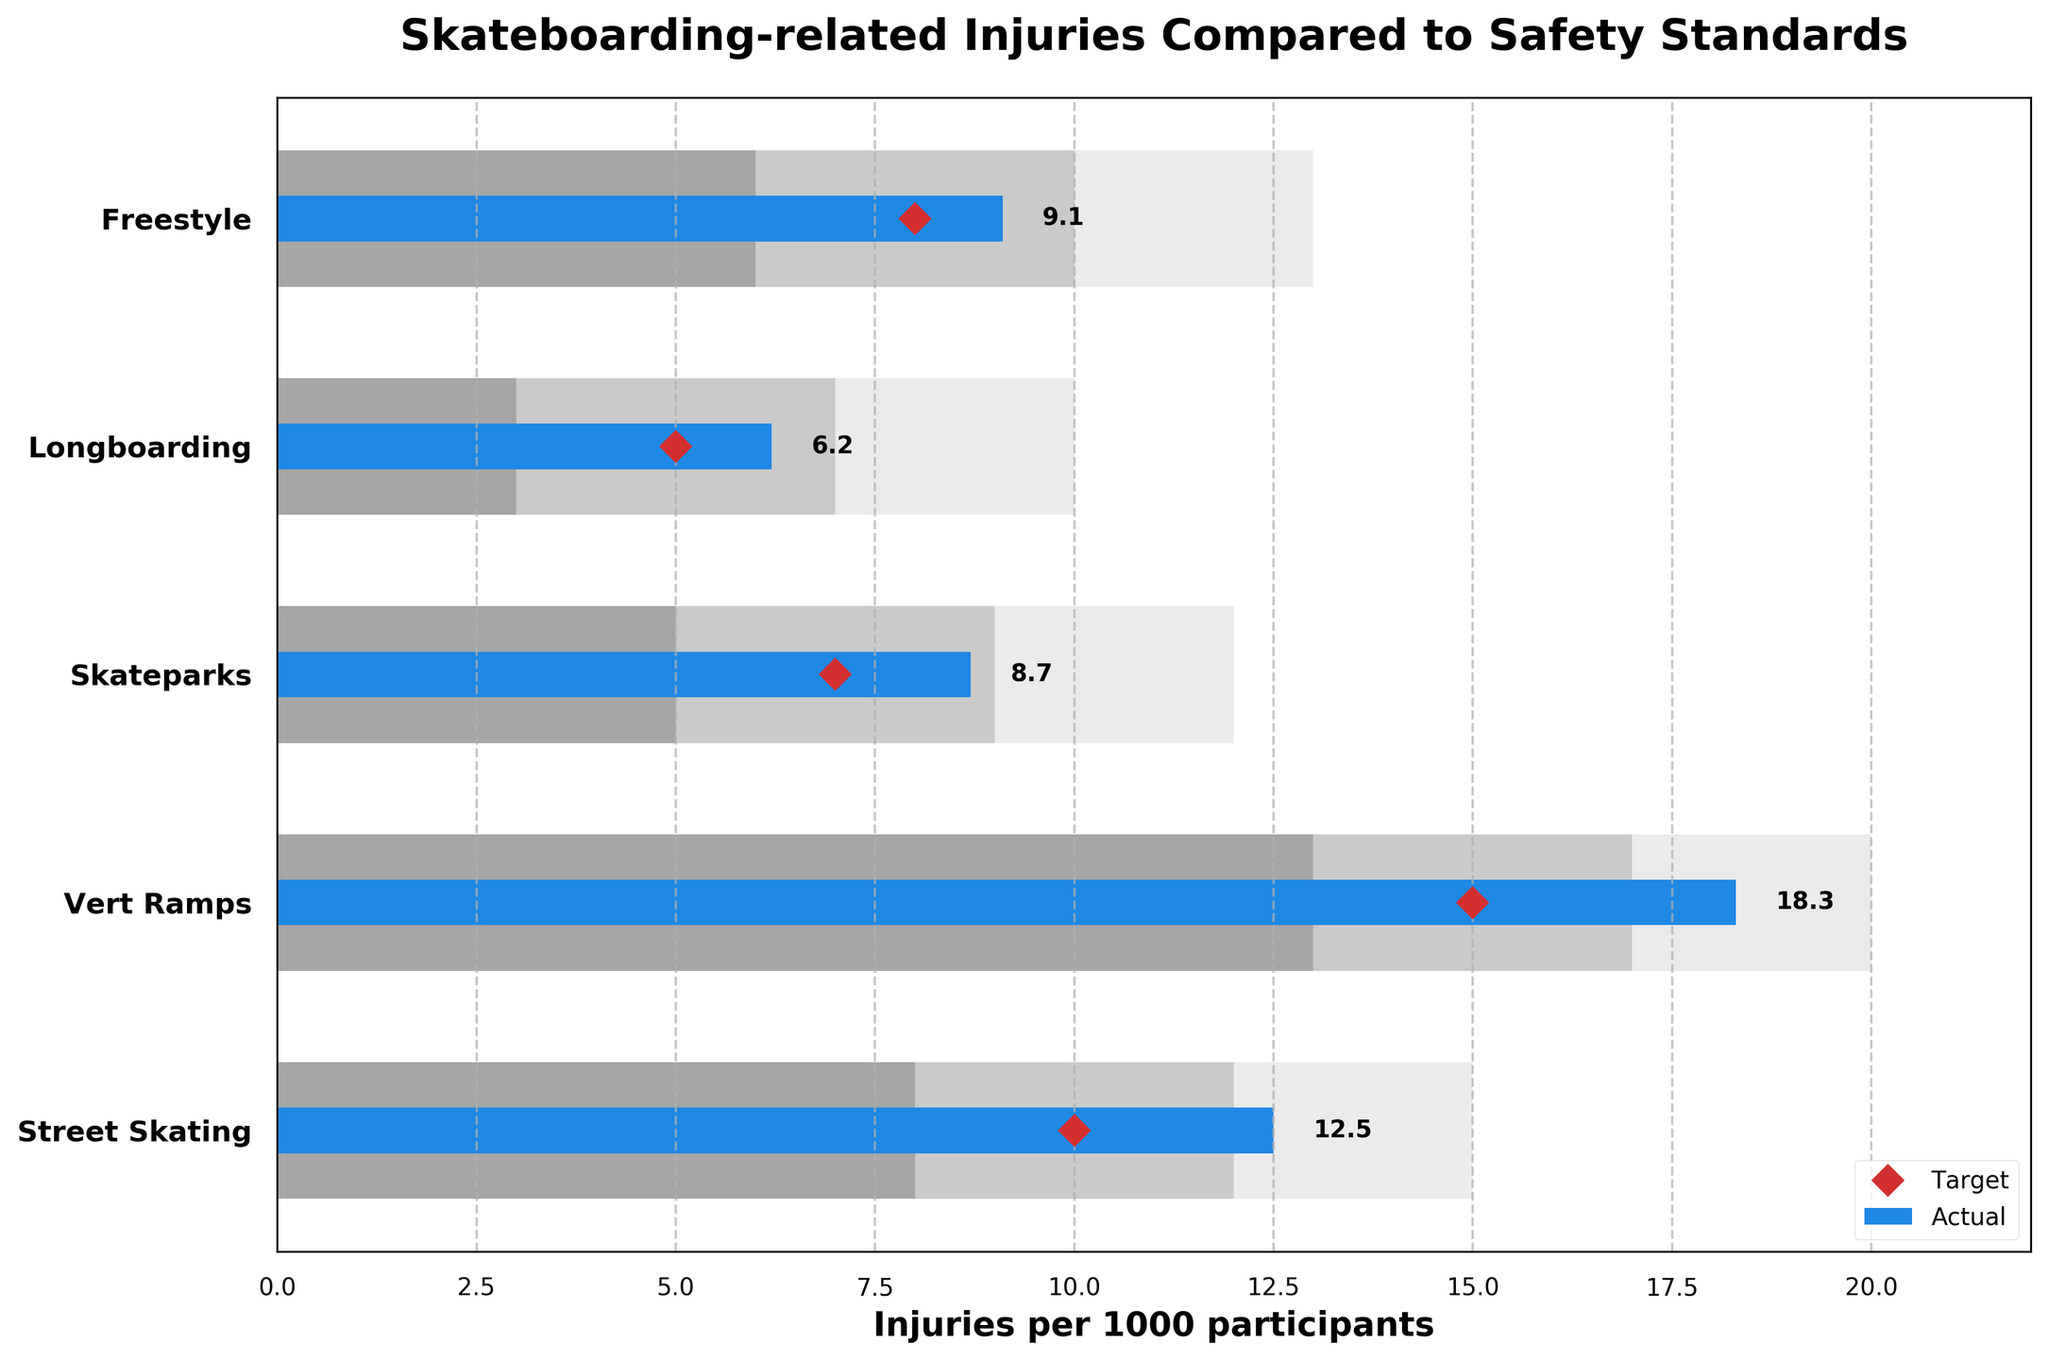What's the title of the figure? The title of the figure is prominently displayed at the top of the chart.
Answer: Skateboarding-related Injuries Compared to Safety Standards How many categories of skateboarding activities are listed? Count the number of distinct categories on the y-axis.
Answer: Five What is the actual number of injuries per 1000 participants for Street Skating? Locate 'Street Skating' on the y-axis and refer to the actual value bar for this category.
Answer: 12.5 Is the actual value of injuries for Vert Ramps higher or lower than the target? Identify the actual value and target value for Vert Ramps and compare them.
Answer: Higher Which skating activity has the lowest number of actual injuries per 1000 participants? Compare the actual value bars for all categories and find the one with the smallest value.
Answer: Longboarding What is the range of satisfactory injuries for Freestyle? Locate the 'Satisfactory' segment for Freestyle and identify the range.
Answer: 10 to 13 Are there any categories where the actual number of injuries is within the good standard? Check if any actual value bars fall within the 'Good' segments for the respective categories.
Answer: No What is the difference between the actual and target injuries for Skateparks? Subtract the target value from the actual value for Skateparks.
Answer: 1.7 (8.7 - 7) Which category has the highest actual number of injuries per 1000 participants? Identify the category with the longest actual value bar.
Answer: Vert Ramps How do the actual injuries for Freestyle compare to Longboarding in terms of the safety standard categories? Compare the actual values of Freestyle and Longboarding and see which safety standard categories they fall into.
Answer: Freestyle is satisfactory; Longboarding is good 